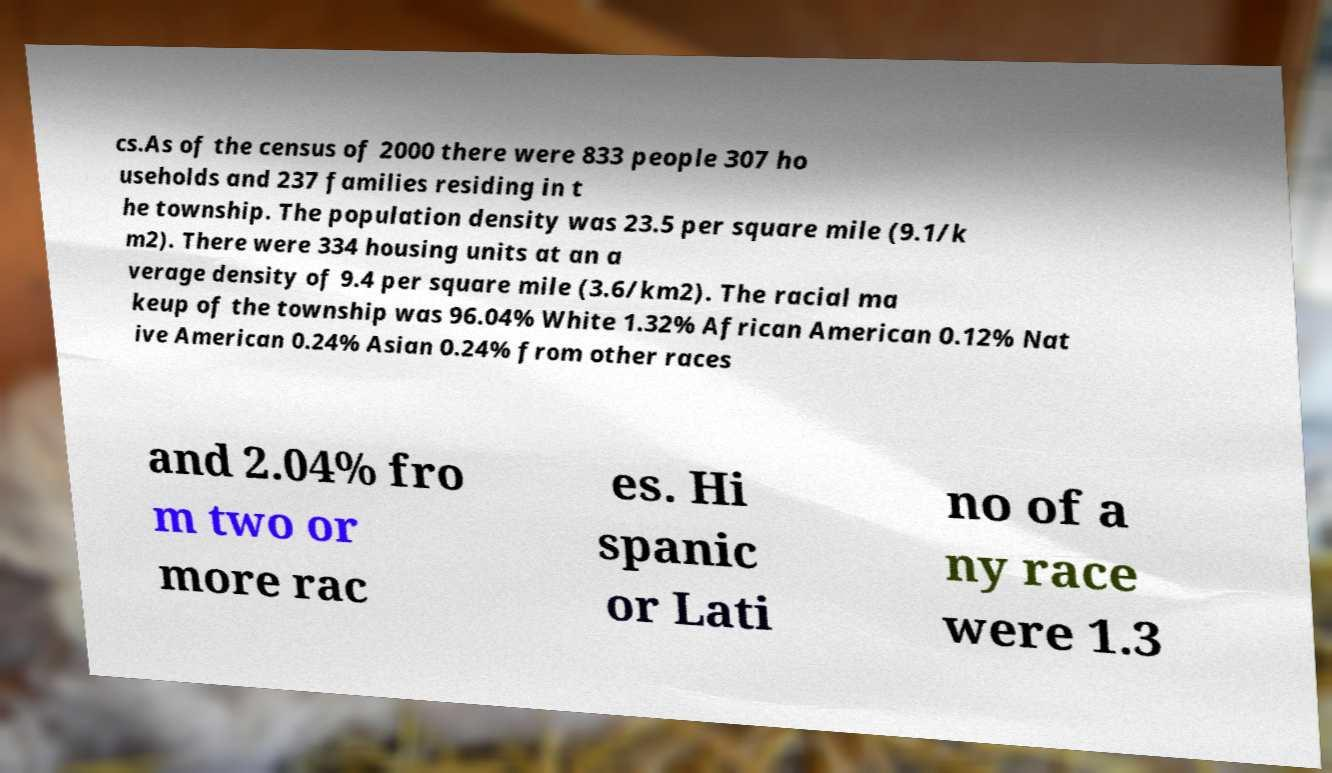I need the written content from this picture converted into text. Can you do that? cs.As of the census of 2000 there were 833 people 307 ho useholds and 237 families residing in t he township. The population density was 23.5 per square mile (9.1/k m2). There were 334 housing units at an a verage density of 9.4 per square mile (3.6/km2). The racial ma keup of the township was 96.04% White 1.32% African American 0.12% Nat ive American 0.24% Asian 0.24% from other races and 2.04% fro m two or more rac es. Hi spanic or Lati no of a ny race were 1.3 